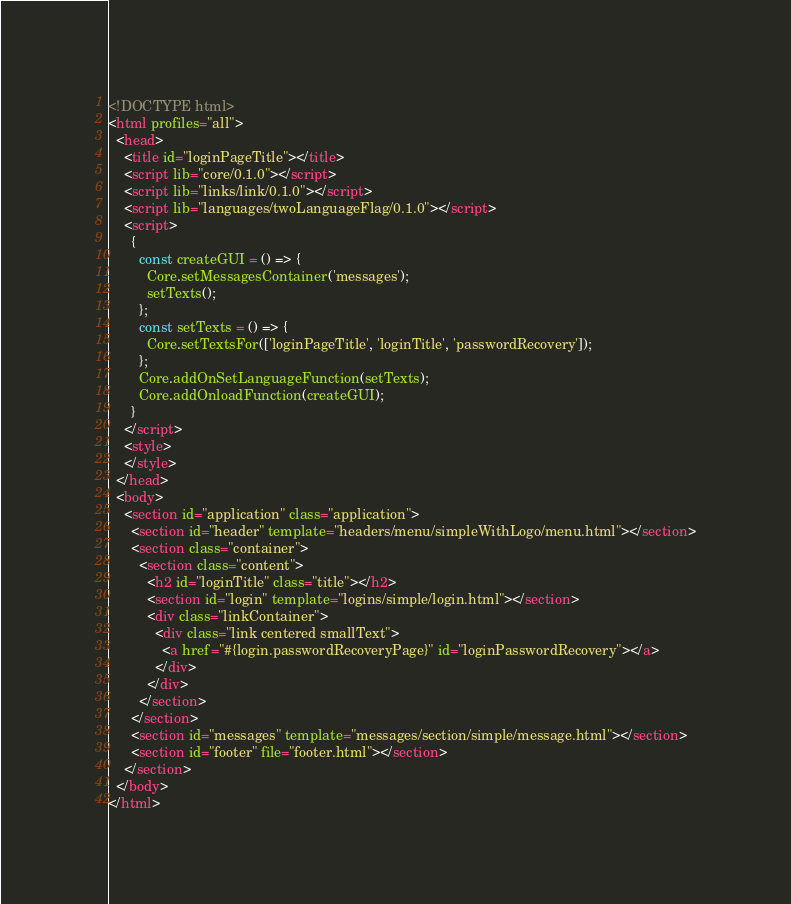<code> <loc_0><loc_0><loc_500><loc_500><_HTML_><!DOCTYPE html>
<html profiles="all">
  <head>
    <title id="loginPageTitle"></title>
    <script lib="core/0.1.0"></script>
    <script lib="links/link/0.1.0"></script>
    <script lib="languages/twoLanguageFlag/0.1.0"></script>
    <script>
      {
        const createGUI = () => {
          Core.setMessagesContainer('messages');
          setTexts();
        };
        const setTexts = () => {
          Core.setTextsFor(['loginPageTitle', 'loginTitle', 'passwordRecovery']);
        };
        Core.addOnSetLanguageFunction(setTexts);
        Core.addOnloadFunction(createGUI);
      }
    </script>
    <style>
    </style>
  </head>
  <body>
    <section id="application" class="application">
      <section id="header" template="headers/menu/simpleWithLogo/menu.html"></section>
      <section class="container">
        <section class="content">
          <h2 id="loginTitle" class="title"></h2>
          <section id="login" template="logins/simple/login.html"></section>
          <div class="linkContainer">
            <div class="link centered smallText">
              <a href="#{login.passwordRecoveryPage}" id="loginPasswordRecovery"></a>
            </div>
          </div>
        </section>
      </section>
      <section id="messages" template="messages/section/simple/message.html"></section>
      <section id="footer" file="footer.html"></section>
    </section>
  </body>
</html></code> 